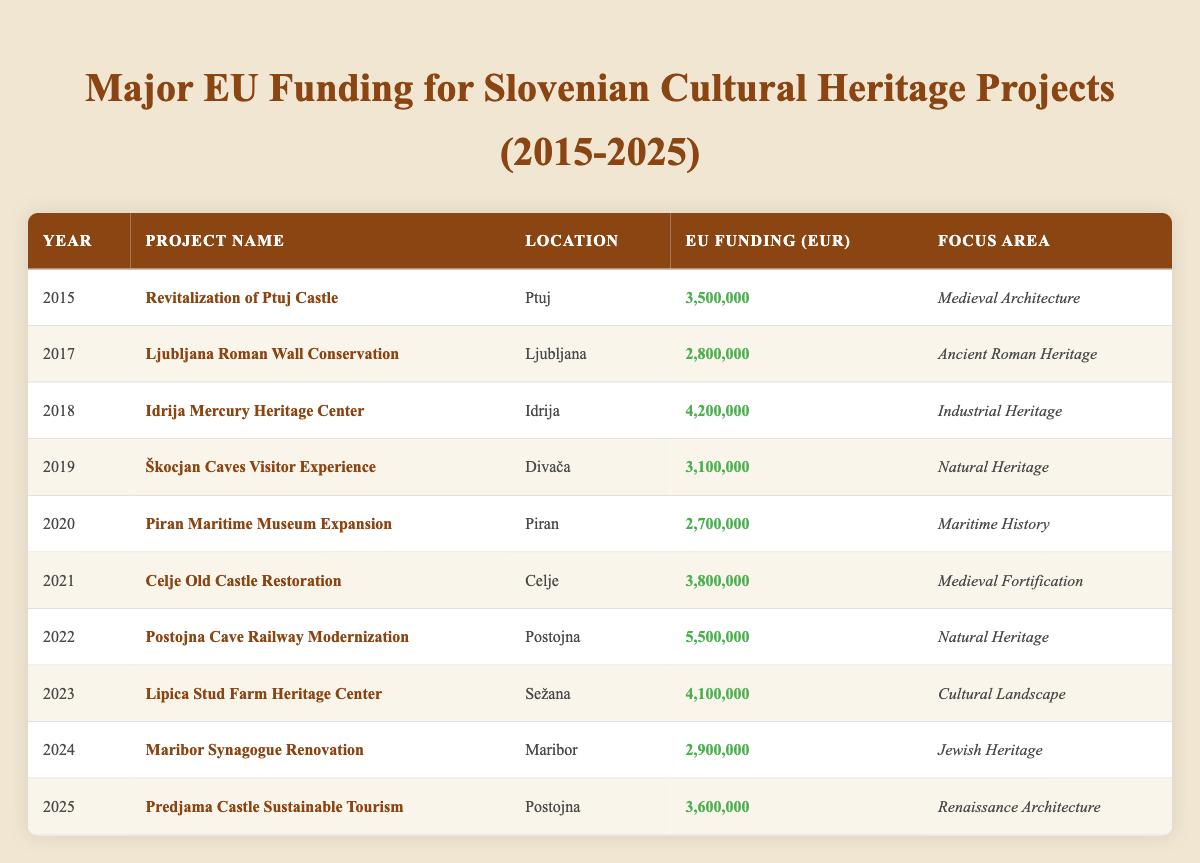What is the largest EU funding allocation for a cultural heritage project in Slovenia between 2015 and 2025? The largest EU funding allocation is for "Postojna Cave Railway Modernization" in 2022, with a total of €5,500,000.
Answer: €5,500,000 In which year was the "Idrija Mercury Heritage Center" project funded, and how much funding did it receive? The "Idrija Mercury Heritage Center" project was funded in 2018 and received €4,200,000.
Answer: 2018, €4,200,000 How much total funding was allocated to natural heritage projects in this time frame? The natural heritage projects are "Škocjan Caves Visitor Experience" in 2019 (€3,100,000) and "Postojna Cave Railway Modernization" in 2022 (€5,500,000). Thus, the total funding = €3,100,000 + €5,500,000 = €8,600,000.
Answer: €8,600,000 Is the funding for "Maribor Synagogue Renovation" greater than the funding for "Piran Maritime Museum Expansion"? The funding for "Maribor Synagogue Renovation" is €2,900,000, while "Piran Maritime Museum Expansion" is €2,700,000, therefore it is true that it is greater.
Answer: Yes Which project received the funding in 2021, and what was its focus area? The project in 2021 is "Celje Old Castle Restoration," which focuses on medieval fortification.
Answer: Celje Old Castle Restoration, Medieval Fortification What is the average funding amount for the projects focusing on medieval architecture between 2015 and 2025? The only project focusing on medieval architecture is "Revitalization of Ptuj Castle" with €3,500,000 in 2015 and "Celje Old Castle Restoration" with €3,800,000 in 2021. The average funding is (3,500,000 + 3,800,000) / 2 = €3,650,000.
Answer: €3,650,000 What percentage of the total EU funding from this data is allocated to industrial heritage projects? The project "Idrija Mercury Heritage Center" is the only one focusing on industrial heritage, receiving €4,200,000 in 2018. The total funding across all projects is €30,900,000. The percentage is (4,200,000 / 30,900,000) * 100 = 13.59%.
Answer: 13.59% How many cultural heritage projects received EU funding in Slovenia in 2023? In 2023, there is one project listed, which is "Lipica Stud Farm Heritage Center."
Answer: 1 Which project had the lowest funding and what was its amount? The project with the lowest funding is "Piran Maritime Museum Expansion," receiving €2,700,000 in 2020.
Answer: Piran Maritime Museum Expansion, €2,700,000 